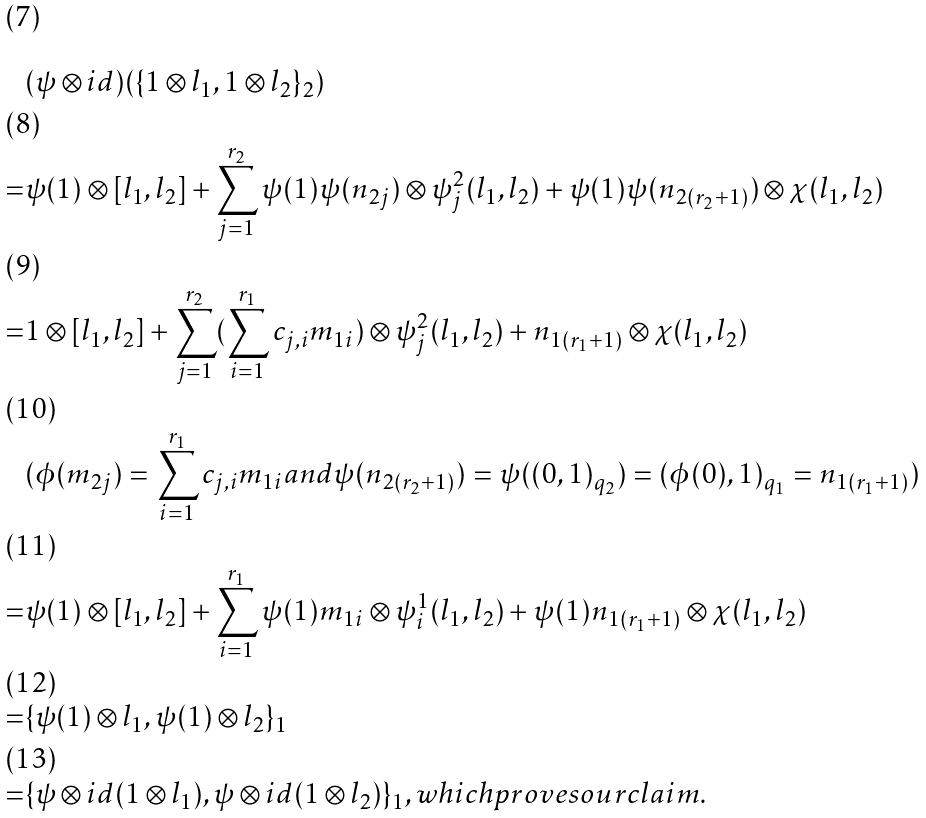Convert formula to latex. <formula><loc_0><loc_0><loc_500><loc_500>& ( \psi \otimes i d ) ( \{ 1 \otimes l _ { 1 } , 1 \otimes l _ { 2 } \} _ { 2 } ) \\ = & \psi ( 1 ) \otimes [ l _ { 1 } , l _ { 2 } ] + \sum _ { j = 1 } ^ { r _ { 2 } } \psi ( 1 ) \psi ( n _ { 2 j } ) \otimes \psi ^ { 2 } _ { j } ( l _ { 1 } , l _ { 2 } ) + \psi ( 1 ) \psi ( n _ { 2 ( r _ { 2 } + 1 ) } ) \otimes \chi ( l _ { 1 } , l _ { 2 } ) \\ = & 1 \otimes [ l _ { 1 } , l _ { 2 } ] + \sum _ { j = 1 } ^ { r _ { 2 } } ( \sum _ { i = 1 } ^ { r _ { 1 } } c _ { j , i } m _ { 1 i } ) \otimes \psi ^ { 2 } _ { j } ( l _ { 1 } , l _ { 2 } ) + n _ { 1 ( r _ { 1 } + 1 ) } \otimes \chi ( l _ { 1 } , l _ { 2 } ) \\ & ( \phi ( m _ { 2 j } ) = \sum _ { i = 1 } ^ { r _ { 1 } } c _ { j , i } m _ { 1 i } a n d \psi ( n _ { 2 ( r _ { 2 } + 1 ) } ) = \psi ( ( 0 , 1 ) _ { q _ { 2 } } ) = ( \phi ( 0 ) , 1 ) _ { q _ { 1 } } = n _ { 1 ( r _ { 1 } + 1 ) } ) \\ = & \psi ( 1 ) \otimes [ l _ { 1 } , l _ { 2 } ] + \sum _ { i = 1 } ^ { r _ { 1 } } \psi ( 1 ) m _ { 1 i } \otimes \psi ^ { 1 } _ { i } ( l _ { 1 } , l _ { 2 } ) + \psi ( 1 ) n _ { 1 ( r _ { 1 } + 1 ) } \otimes \chi ( l _ { 1 } , l _ { 2 } ) \\ = & \{ \psi ( 1 ) \otimes l _ { 1 } , \psi ( 1 ) \otimes l _ { 2 } \} _ { 1 } \\ = & \{ \psi \otimes i d ( 1 \otimes l _ { 1 } ) , \psi \otimes i d ( 1 \otimes l _ { 2 } ) \} _ { 1 } , w h i c h p r o v e s o u r c l a i m .</formula> 